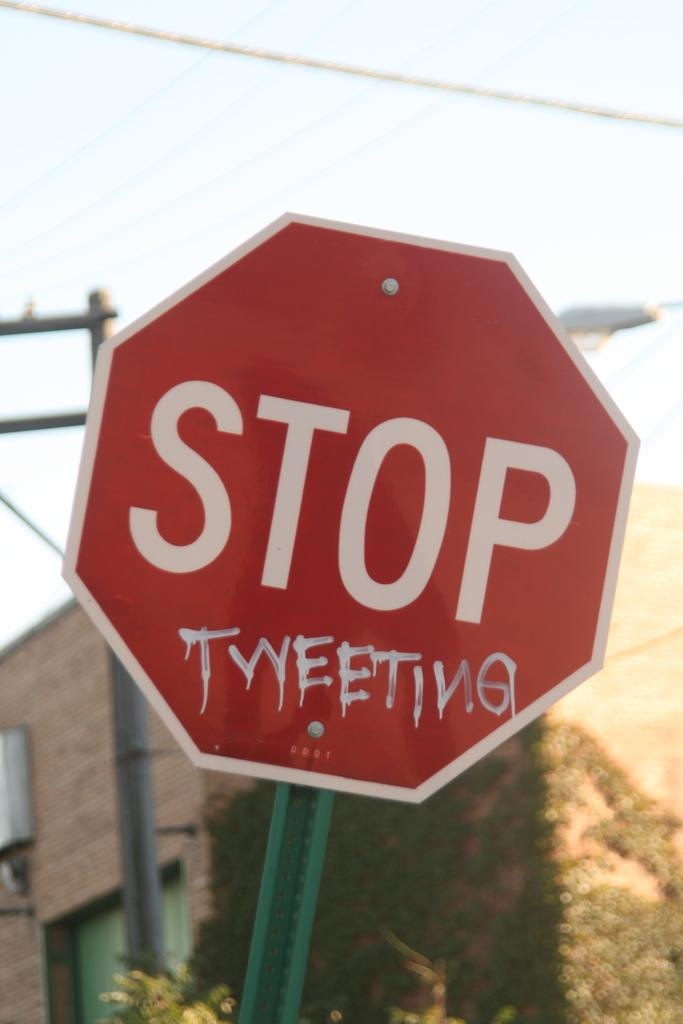<image>
Create a compact narrative representing the image presented. A red octagon sign that states STOP TWEETING 